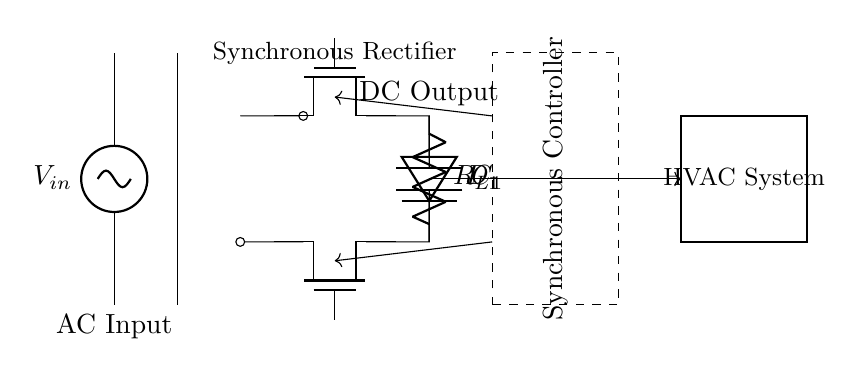What type of rectifier is this? This circuit diagram illustrates a synchronous rectifier which utilizes controlled switching (using MOSFETs) instead of diodes to improve efficiency. The presence of the Tnmos components as part of the rectifying circuit indicates this type.
Answer: Synchronous rectifier What is the role of the transformer in this circuit? The transformer in this circuit steps down or steps up the input AC voltage to a desired level before it reaches the rectifier stage. It converts the voltage while maintaining the same frequency and is essential for appropriate voltage levels for the HVAC system.
Answer: Voltage conversion What components are used for the rectification process? The rectification process in this diagram uses two MOSFETs (labeled as M1 and M2) and an asynchronous diode (D1). The MOSFETs function as controlled switches to allow current flow in the desired direction, effectively switching as needed based on the control signals.
Answer: Two MOSFETs and one diode What does the dashed rectangle represent? The dashed rectangle indicates the area of the synchronous controller, which regulates the operation of the MOSFETs in the rectifier to optimize efficiency and maintain the desired output voltage. This controller is crucial in managing the timing of the MOSFET switching.
Answer: Synchronous controller What is the function of the capacitor in this circuit? The capacitor (C1) in the circuit acts as a smoothing element by stabilizing the output voltage. It helps reduce voltage ripple after rectification, providing a more consistent DC voltage that can be effectively used by the HVAC system.
Answer: Smoothing output voltage How does the control signal impact the MOSFETs? The control signals from the synchronous controller activate the MOSFETs at specific intervals to allow current to pass during the correct phase of the input AC signal. This precise timing ensures that the rectification is done efficiently, minimizing conduction losses.
Answer: Activates MOSFETs 